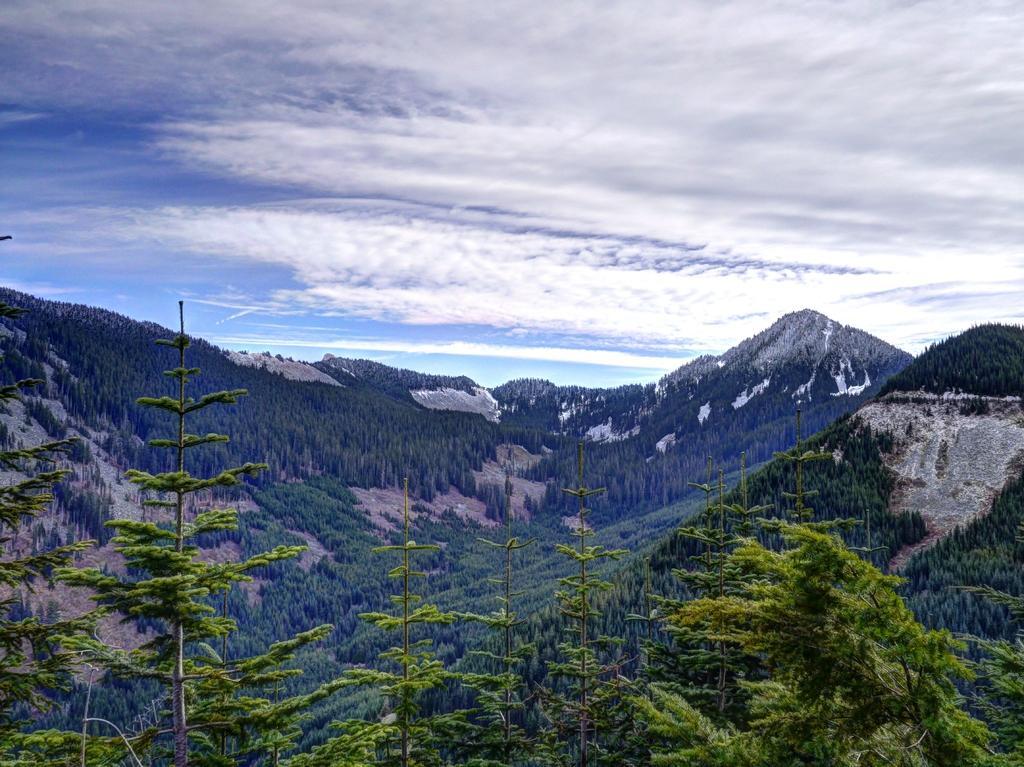How would you summarize this image in a sentence or two? In the image we can see there are many trees, this is a mountain and a cloudy sky. 